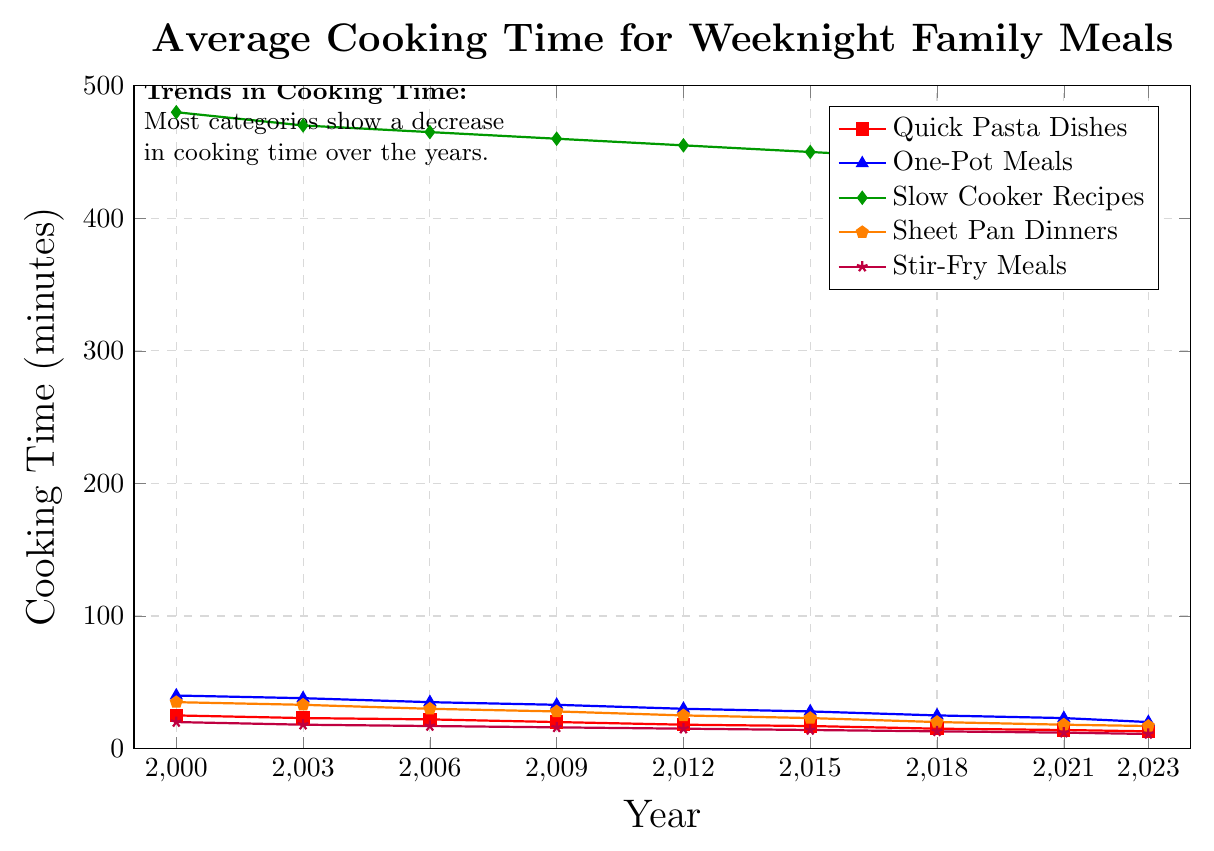Which recipe category had the highest average cooking time in 2000? According to the chart, among the different categories, the one with the highest average cooking time in 2000 is represented by the highest value on the y-axis. The highest value in 2000 is for Slow Cooker Recipes, which has a cooking time of 480 minutes.
Answer: Slow Cooker Recipes Between 2000 and 2023, which recipe category showed the greatest decrease in cooking time? To determine the category with the greatest decrease, we need to compare the cooking time in 2000 and 2023 for each category and calculate the differences. Slow Cooker Recipes decreased by 480 - 435 = 45 minutes, Quick Pasta Dishes by 25 - 13 = 12 minutes, One-Pot Meals by 40 - 20 = 20 minutes, Sheet Pan Dinners by 35 - 17 = 18 minutes, and Stir-Fry Meals by 20 - 11 = 9 minutes. The greatest decrease is thus for Slow Cooker Recipes with a 45-minute reduction.
Answer: Slow Cooker Recipes What is the overall trend observed in cooking times from 2000 to 2023? Observing all categories on the chart, it's evident that the cooking times for each category have decreased over the years. This trend is indicated by the downward slopes of all lines from 2000 to 2023.
Answer: Decreasing In 2023, which recipes take less than 20 minutes to cook on average? Looking at the graph for data points in 2023, we need to identify all categories with values less than 20 on the y-axis. Quick Pasta Dishes (13 minutes), One-Pot Meals (20 minutes), Sheet Pan Dinners (17 minutes), and Stir-Fry Meals (11 minutes) fall into this category.
Answer: Quick Pasta Dishes, One-Pot Meals, Sheet Pan Dinners, Stir-Fry Meals Which category had the smallest decrease in cooking time from 2000 to 2023? We need to compute the decrease for each category and identify the smallest. Calculations: Quick Pasta Dishes: 25 - 13 = 12 minutes, One-Pot Meals: 40 - 20 = 20 minutes, Slow Cooker Recipes: 480 - 435 = 45 minutes, Sheet Pan Dinners: 35 - 17 = 18 minutes, and Stir-Fry Meals: 20 - 11 = 9 minutes. The smallest decrease is for Stir-Fry Meals, with a 9-minute reduction.
Answer: Stir-Fry Meals How much did the cooking time for Quick Pasta Dishes decrease between 2000 and 2018? We find the cooking times in 2000 and 2018 for Quick Pasta Dishes, which are 25 and 15 minutes, respectively. The decrease is 25 - 15 = 10 minutes.
Answer: 10 minutes How did the cooking time for Stir-Fry Meals change between 2006 and 2015? Identifying the values for Stir-Fry Meals in 2006 (17 minutes) and 2015 (14 minutes), we find the decrease by subtracting the latter from the former: 17 - 14 = 3 minutes.
Answer: Decreased by 3 minutes 